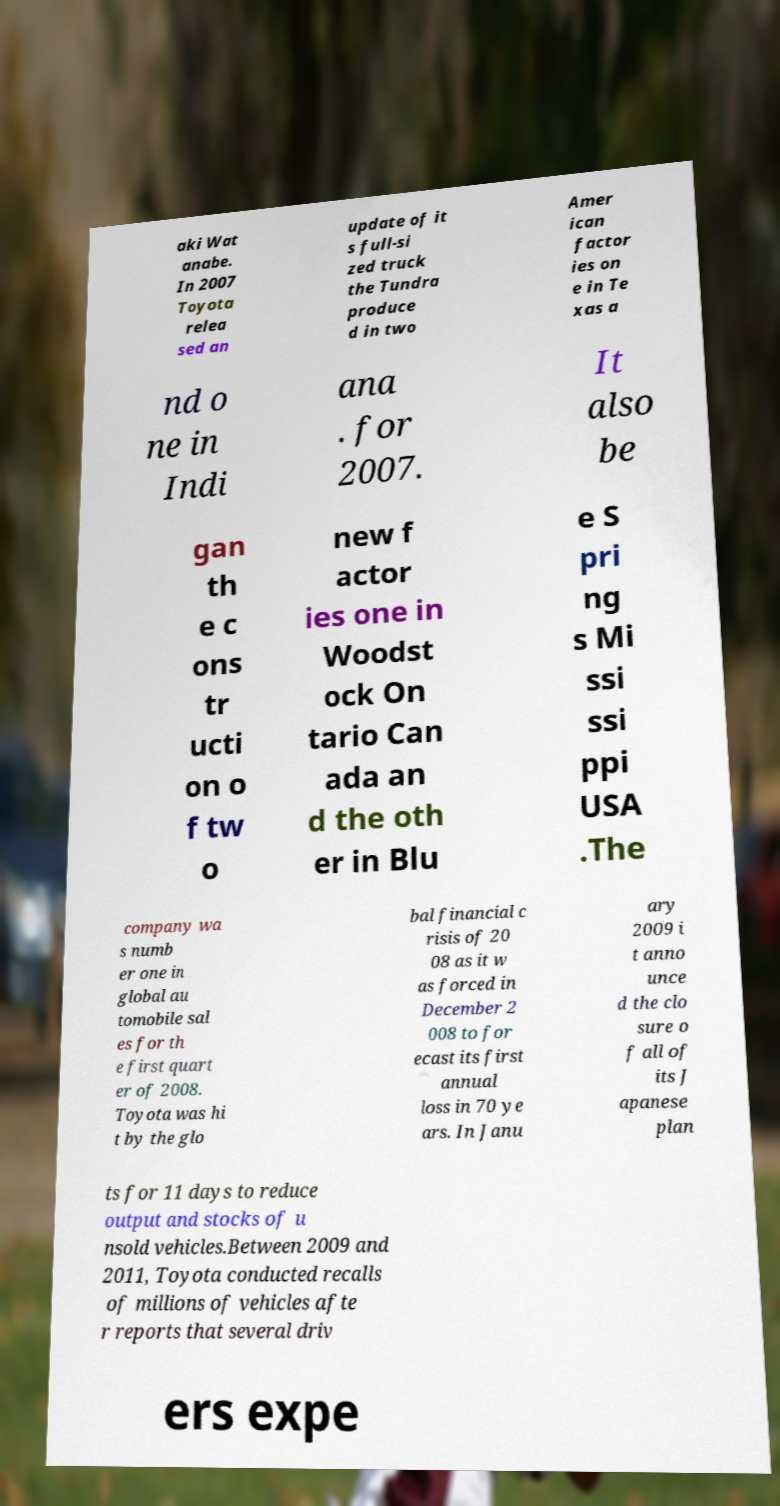Could you extract and type out the text from this image? aki Wat anabe. In 2007 Toyota relea sed an update of it s full-si zed truck the Tundra produce d in two Amer ican factor ies on e in Te xas a nd o ne in Indi ana . for 2007. It also be gan th e c ons tr ucti on o f tw o new f actor ies one in Woodst ock On tario Can ada an d the oth er in Blu e S pri ng s Mi ssi ssi ppi USA .The company wa s numb er one in global au tomobile sal es for th e first quart er of 2008. Toyota was hi t by the glo bal financial c risis of 20 08 as it w as forced in December 2 008 to for ecast its first annual loss in 70 ye ars. In Janu ary 2009 i t anno unce d the clo sure o f all of its J apanese plan ts for 11 days to reduce output and stocks of u nsold vehicles.Between 2009 and 2011, Toyota conducted recalls of millions of vehicles afte r reports that several driv ers expe 